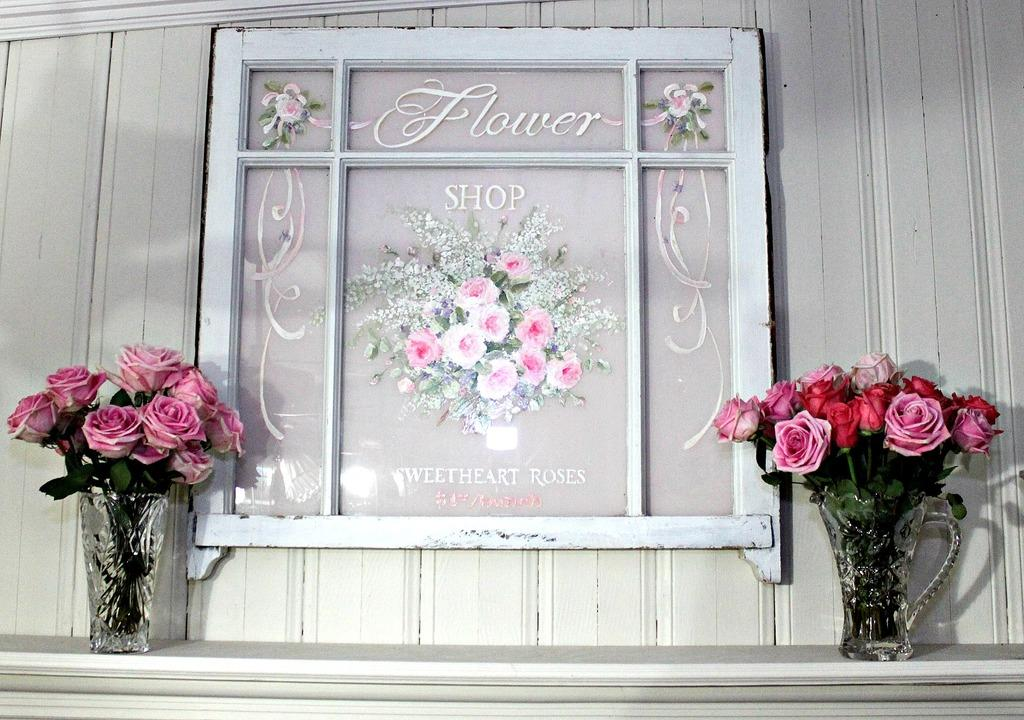What object is present in the image that holds flowers? There is a flower vase in the image. What type of flowers are in the vase? There are rose flowers in the image. What is the object next to the vase that holds a picture? There is a photo frame in the image. What is written or printed on the photo frame? There is text on the photo frame. What can be seen behind the vase and photo frame? There is a wall in the background of the image. What type of chalk is being used to draw on the wall in the image? There is no chalk or drawing on the wall in the image. Is there a servant present in the image? There is no servant present in the image. 